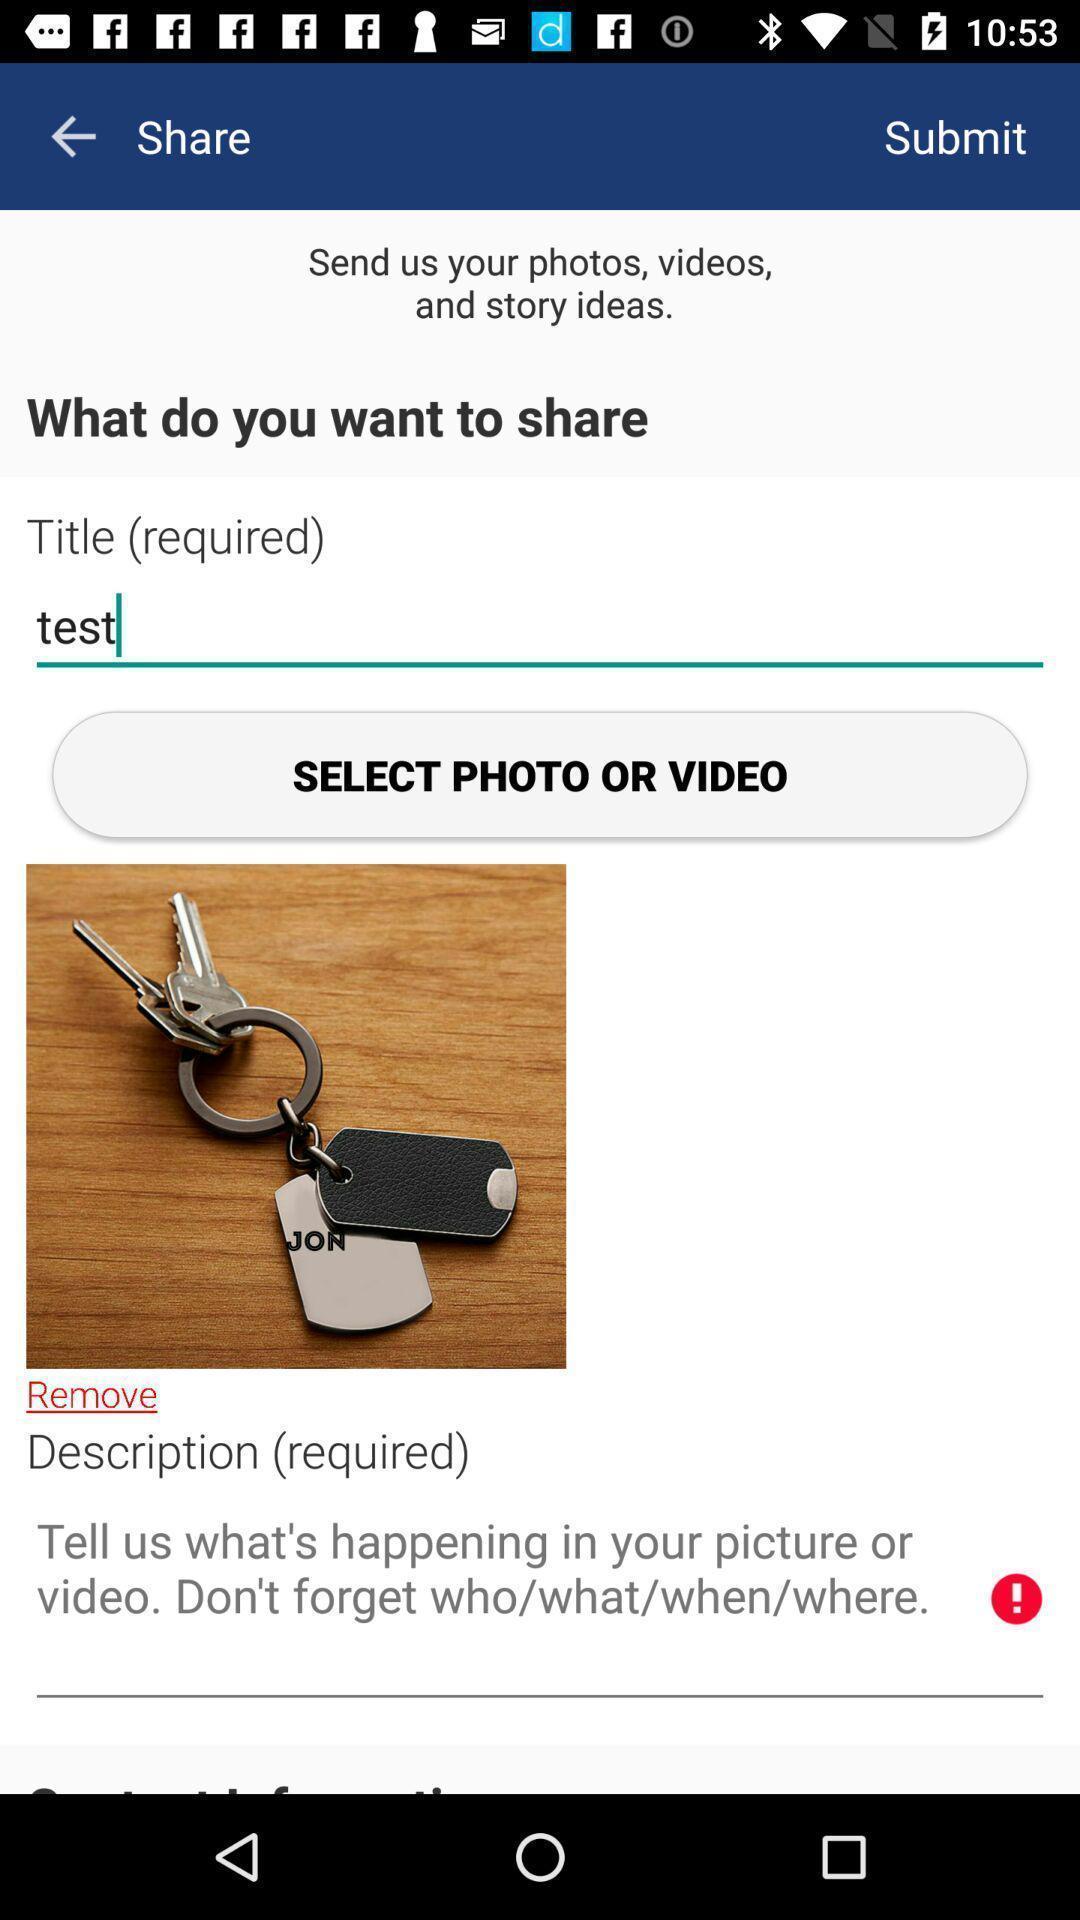Explain the elements present in this screenshot. Screen showing description and select option. 